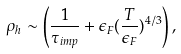Convert formula to latex. <formula><loc_0><loc_0><loc_500><loc_500>\rho _ { h } \sim \left ( \frac { 1 } { \tau _ { i m p } } + \epsilon _ { F } ( \frac { T } { \epsilon _ { F } } ) ^ { 4 / 3 } \right ) ,</formula> 